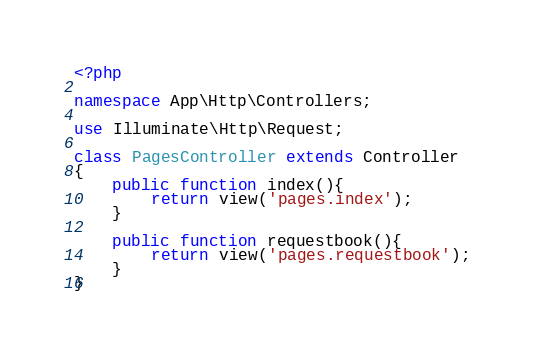Convert code to text. <code><loc_0><loc_0><loc_500><loc_500><_PHP_><?php

namespace App\Http\Controllers;

use Illuminate\Http\Request;

class PagesController extends Controller
{
    public function index(){
        return view('pages.index');
    }

    public function requestbook(){
        return view('pages.requestbook');
    }
}
</code> 